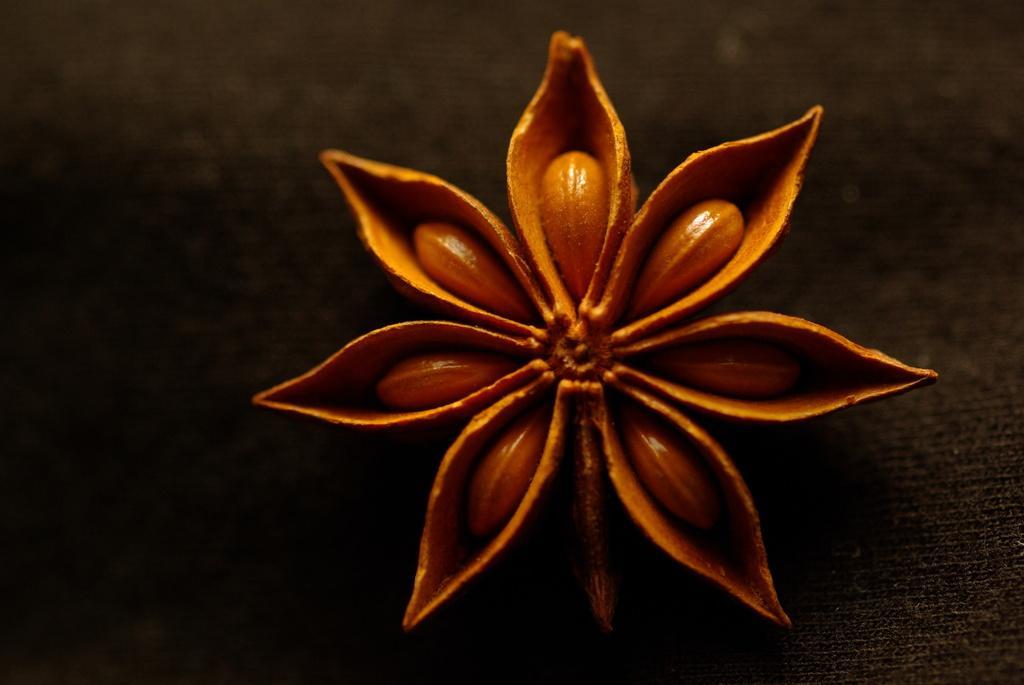Please provide a concise description of this image. Here in this picture we can see a symbol of anise present over there. 